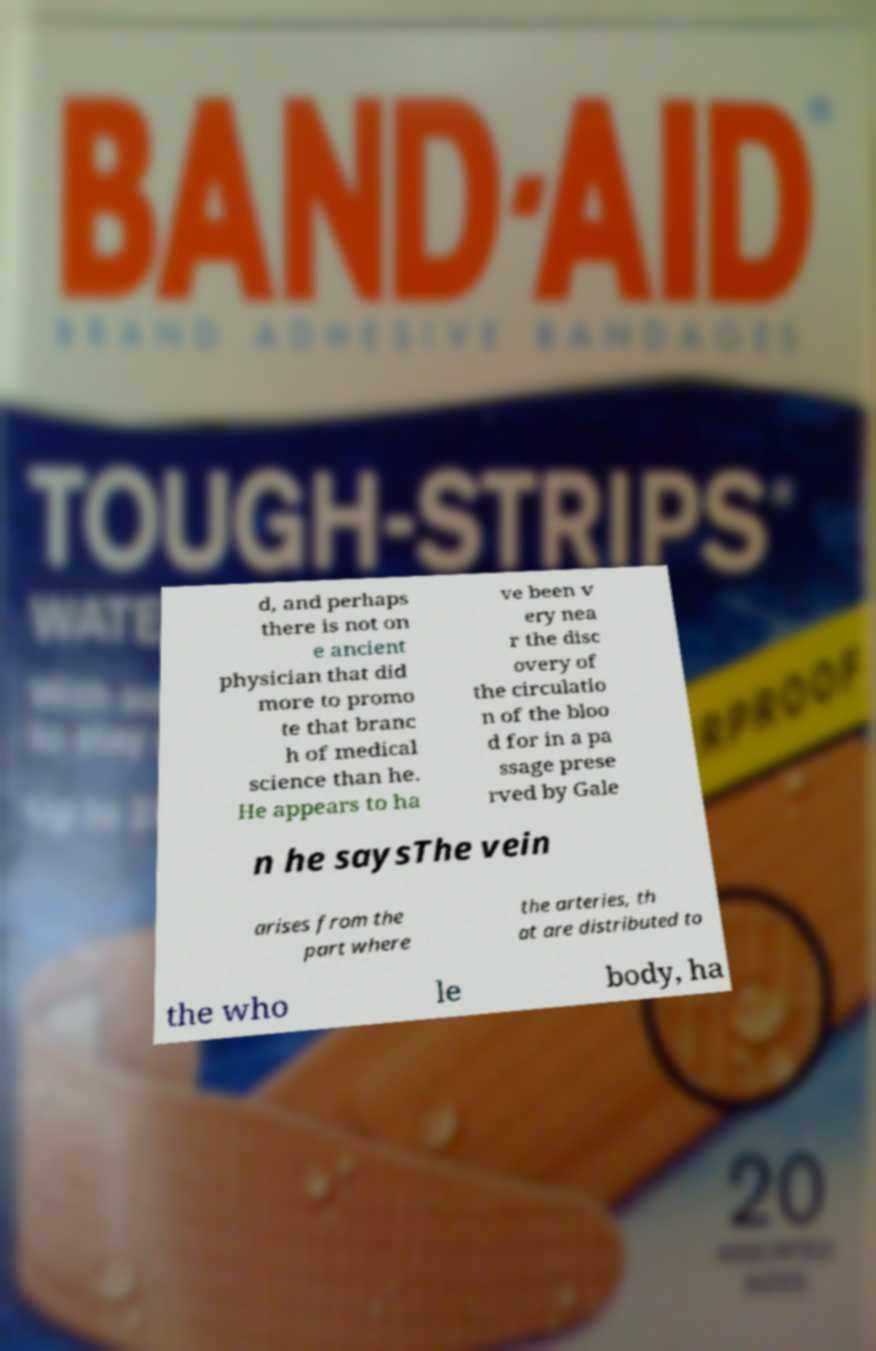Can you accurately transcribe the text from the provided image for me? d, and perhaps there is not on e ancient physician that did more to promo te that branc h of medical science than he. He appears to ha ve been v ery nea r the disc overy of the circulatio n of the bloo d for in a pa ssage prese rved by Gale n he saysThe vein arises from the part where the arteries, th at are distributed to the who le body, ha 